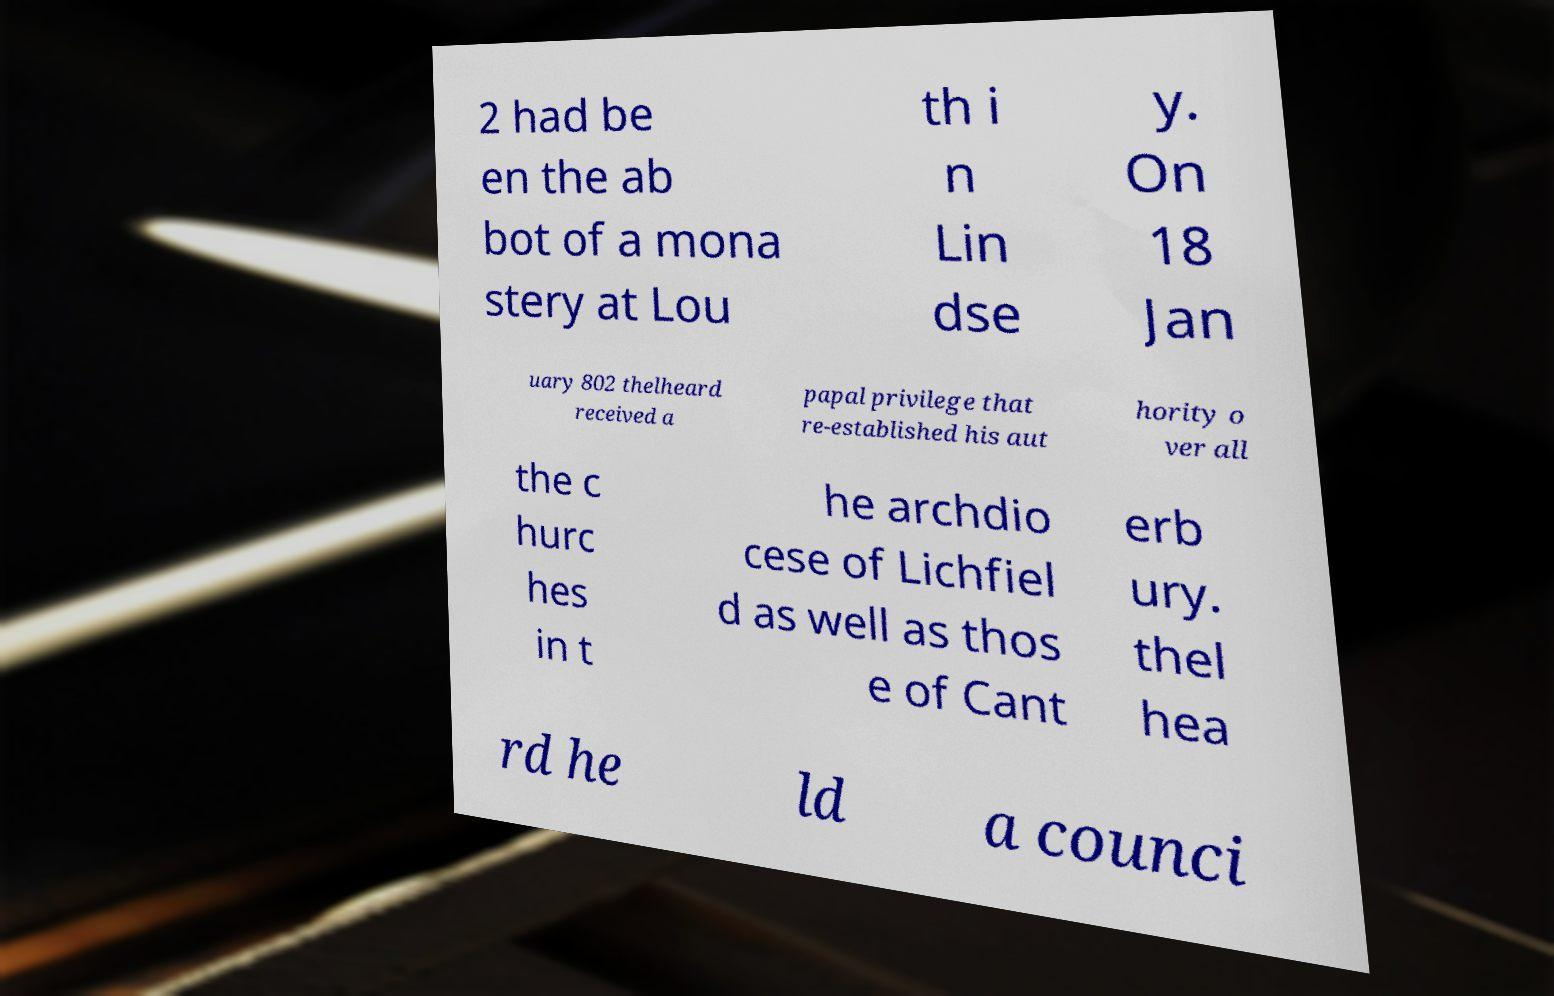Please read and relay the text visible in this image. What does it say? 2 had be en the ab bot of a mona stery at Lou th i n Lin dse y. On 18 Jan uary 802 thelheard received a papal privilege that re-established his aut hority o ver all the c hurc hes in t he archdio cese of Lichfiel d as well as thos e of Cant erb ury. thel hea rd he ld a counci 